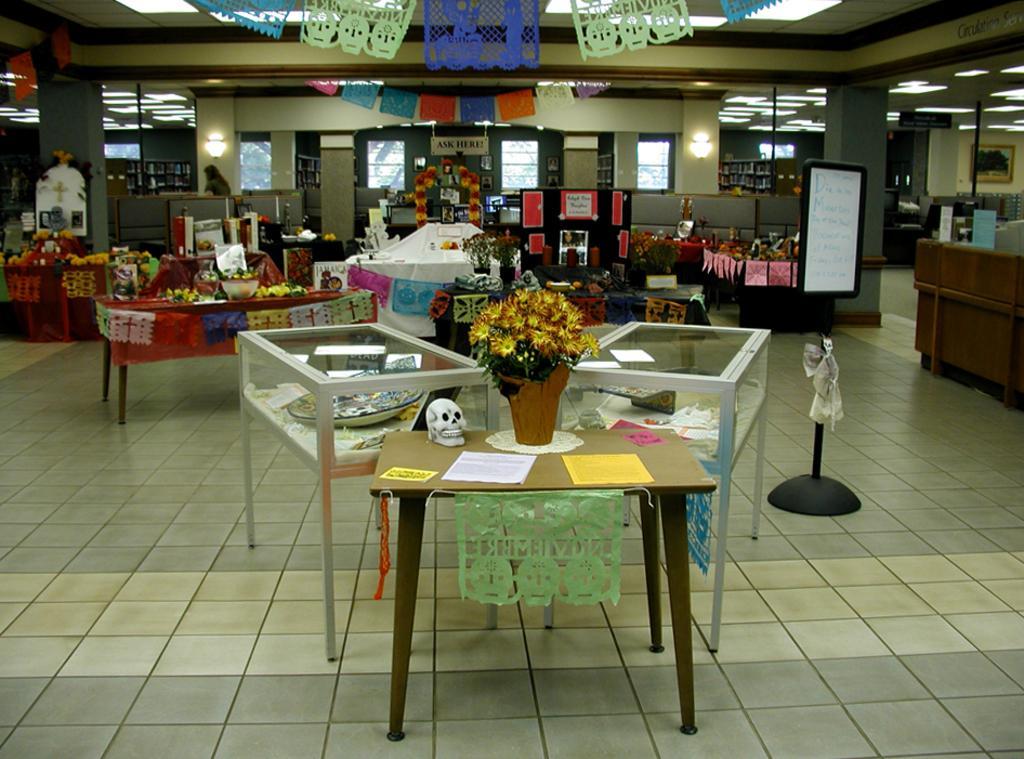How would you summarize this image in a sentence or two? In this image there are tables , and on tables there are papers, skulls, flower vases , and some decorative items , and at the background there are lights and frames attached to wall, some ceramic items inside the glass boxes, boards , ribbons , flowers, books in the racks. 